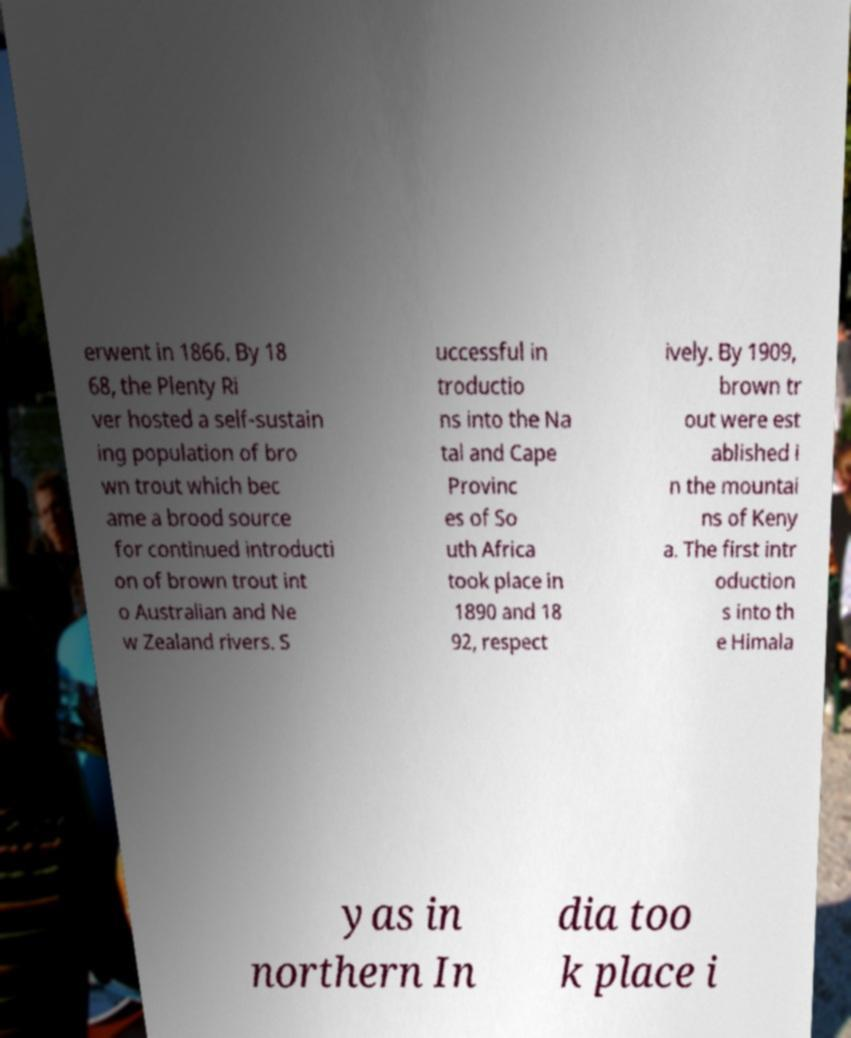For documentation purposes, I need the text within this image transcribed. Could you provide that? erwent in 1866. By 18 68, the Plenty Ri ver hosted a self-sustain ing population of bro wn trout which bec ame a brood source for continued introducti on of brown trout int o Australian and Ne w Zealand rivers. S uccessful in troductio ns into the Na tal and Cape Provinc es of So uth Africa took place in 1890 and 18 92, respect ively. By 1909, brown tr out were est ablished i n the mountai ns of Keny a. The first intr oduction s into th e Himala yas in northern In dia too k place i 